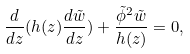<formula> <loc_0><loc_0><loc_500><loc_500>\frac { d } { d z } ( h ( z ) \frac { d \tilde { w } } { d z } ) + \frac { \tilde { \phi } ^ { 2 } \tilde { w } } { h ( z ) } = 0 ,</formula> 